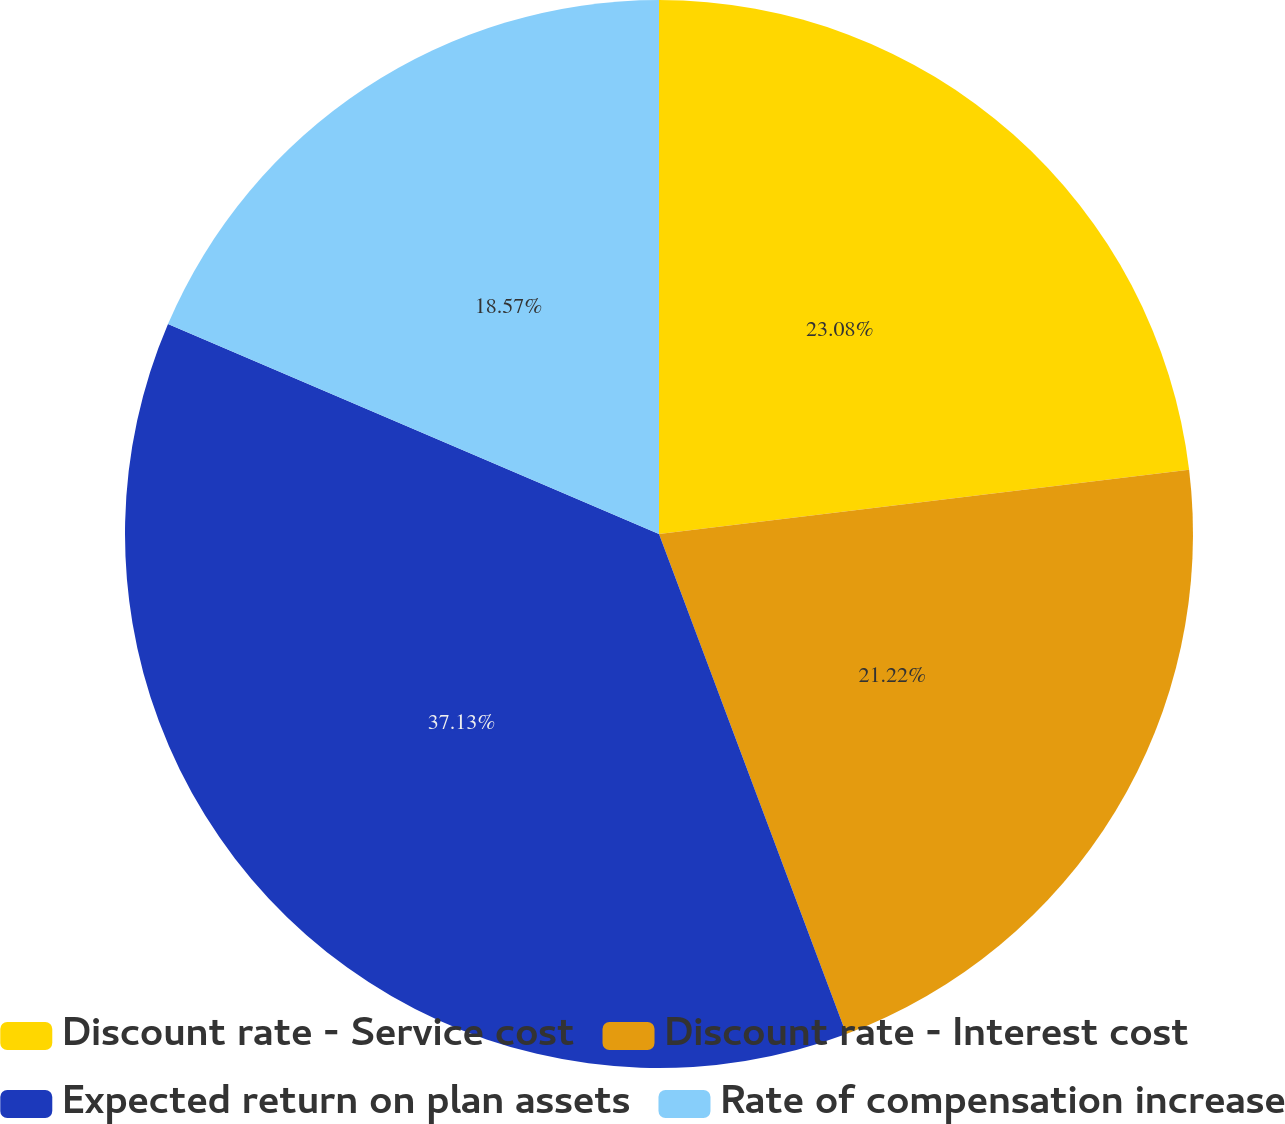<chart> <loc_0><loc_0><loc_500><loc_500><pie_chart><fcel>Discount rate - Service cost<fcel>Discount rate - Interest cost<fcel>Expected return on plan assets<fcel>Rate of compensation increase<nl><fcel>23.08%<fcel>21.22%<fcel>37.14%<fcel>18.57%<nl></chart> 